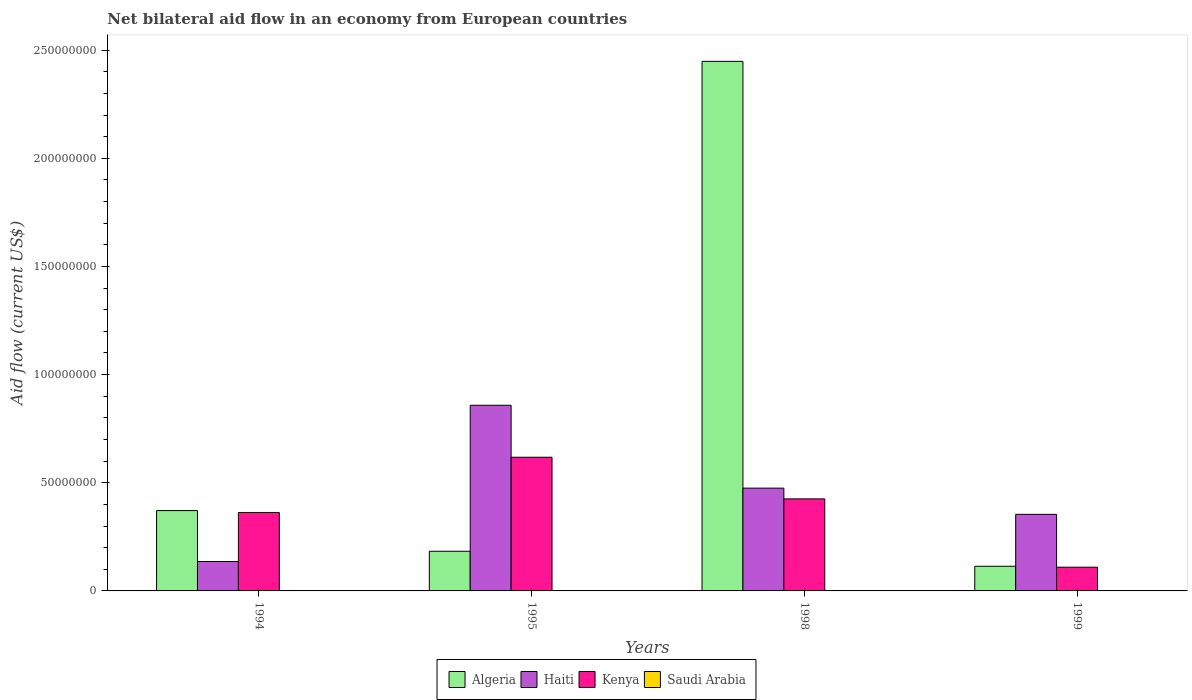How many bars are there on the 3rd tick from the left?
Offer a terse response. 4. What is the label of the 3rd group of bars from the left?
Offer a very short reply. 1998. In how many cases, is the number of bars for a given year not equal to the number of legend labels?
Offer a terse response. 0. What is the net bilateral aid flow in Kenya in 1998?
Offer a very short reply. 4.25e+07. Across all years, what is the maximum net bilateral aid flow in Haiti?
Your answer should be compact. 8.58e+07. Across all years, what is the minimum net bilateral aid flow in Algeria?
Your answer should be very brief. 1.14e+07. In which year was the net bilateral aid flow in Algeria maximum?
Provide a succinct answer. 1998. What is the total net bilateral aid flow in Algeria in the graph?
Your answer should be very brief. 3.12e+08. What is the difference between the net bilateral aid flow in Algeria in 1998 and the net bilateral aid flow in Kenya in 1995?
Your response must be concise. 1.83e+08. What is the average net bilateral aid flow in Algeria per year?
Provide a succinct answer. 7.79e+07. In the year 1994, what is the difference between the net bilateral aid flow in Algeria and net bilateral aid flow in Kenya?
Provide a succinct answer. 8.90e+05. In how many years, is the net bilateral aid flow in Algeria greater than 50000000 US$?
Offer a terse response. 1. What is the ratio of the net bilateral aid flow in Kenya in 1995 to that in 1998?
Your answer should be compact. 1.45. Is the net bilateral aid flow in Saudi Arabia in 1998 less than that in 1999?
Your response must be concise. Yes. What is the difference between the highest and the second highest net bilateral aid flow in Kenya?
Your answer should be very brief. 1.93e+07. What is the difference between the highest and the lowest net bilateral aid flow in Algeria?
Ensure brevity in your answer.  2.33e+08. Is it the case that in every year, the sum of the net bilateral aid flow in Haiti and net bilateral aid flow in Kenya is greater than the sum of net bilateral aid flow in Saudi Arabia and net bilateral aid flow in Algeria?
Give a very brief answer. No. What does the 2nd bar from the left in 1999 represents?
Offer a terse response. Haiti. What does the 2nd bar from the right in 1994 represents?
Offer a very short reply. Kenya. How many bars are there?
Offer a terse response. 16. Are all the bars in the graph horizontal?
Give a very brief answer. No. What is the difference between two consecutive major ticks on the Y-axis?
Ensure brevity in your answer.  5.00e+07. Does the graph contain any zero values?
Keep it short and to the point. No. Does the graph contain grids?
Your answer should be very brief. No. Where does the legend appear in the graph?
Provide a succinct answer. Bottom center. How many legend labels are there?
Your response must be concise. 4. What is the title of the graph?
Your answer should be very brief. Net bilateral aid flow in an economy from European countries. What is the label or title of the X-axis?
Give a very brief answer. Years. What is the Aid flow (current US$) of Algeria in 1994?
Keep it short and to the point. 3.71e+07. What is the Aid flow (current US$) of Haiti in 1994?
Offer a terse response. 1.36e+07. What is the Aid flow (current US$) in Kenya in 1994?
Keep it short and to the point. 3.62e+07. What is the Aid flow (current US$) in Algeria in 1995?
Give a very brief answer. 1.83e+07. What is the Aid flow (current US$) of Haiti in 1995?
Ensure brevity in your answer.  8.58e+07. What is the Aid flow (current US$) in Kenya in 1995?
Make the answer very short. 6.18e+07. What is the Aid flow (current US$) of Algeria in 1998?
Give a very brief answer. 2.45e+08. What is the Aid flow (current US$) of Haiti in 1998?
Provide a short and direct response. 4.75e+07. What is the Aid flow (current US$) in Kenya in 1998?
Make the answer very short. 4.25e+07. What is the Aid flow (current US$) of Saudi Arabia in 1998?
Your answer should be very brief. 10000. What is the Aid flow (current US$) in Algeria in 1999?
Offer a terse response. 1.14e+07. What is the Aid flow (current US$) of Haiti in 1999?
Your answer should be very brief. 3.54e+07. What is the Aid flow (current US$) in Kenya in 1999?
Provide a succinct answer. 1.10e+07. What is the Aid flow (current US$) in Saudi Arabia in 1999?
Provide a succinct answer. 8.00e+04. Across all years, what is the maximum Aid flow (current US$) of Algeria?
Your response must be concise. 2.45e+08. Across all years, what is the maximum Aid flow (current US$) of Haiti?
Ensure brevity in your answer.  8.58e+07. Across all years, what is the maximum Aid flow (current US$) of Kenya?
Give a very brief answer. 6.18e+07. Across all years, what is the maximum Aid flow (current US$) in Saudi Arabia?
Provide a short and direct response. 1.60e+05. Across all years, what is the minimum Aid flow (current US$) in Algeria?
Provide a short and direct response. 1.14e+07. Across all years, what is the minimum Aid flow (current US$) of Haiti?
Ensure brevity in your answer.  1.36e+07. Across all years, what is the minimum Aid flow (current US$) in Kenya?
Keep it short and to the point. 1.10e+07. What is the total Aid flow (current US$) of Algeria in the graph?
Ensure brevity in your answer.  3.12e+08. What is the total Aid flow (current US$) in Haiti in the graph?
Ensure brevity in your answer.  1.82e+08. What is the total Aid flow (current US$) in Kenya in the graph?
Offer a very short reply. 1.52e+08. What is the total Aid flow (current US$) in Saudi Arabia in the graph?
Provide a succinct answer. 3.60e+05. What is the difference between the Aid flow (current US$) of Algeria in 1994 and that in 1995?
Your answer should be very brief. 1.88e+07. What is the difference between the Aid flow (current US$) in Haiti in 1994 and that in 1995?
Make the answer very short. -7.22e+07. What is the difference between the Aid flow (current US$) of Kenya in 1994 and that in 1995?
Offer a terse response. -2.56e+07. What is the difference between the Aid flow (current US$) in Saudi Arabia in 1994 and that in 1995?
Your response must be concise. -5.00e+04. What is the difference between the Aid flow (current US$) of Algeria in 1994 and that in 1998?
Give a very brief answer. -2.08e+08. What is the difference between the Aid flow (current US$) of Haiti in 1994 and that in 1998?
Your answer should be compact. -3.39e+07. What is the difference between the Aid flow (current US$) in Kenya in 1994 and that in 1998?
Your answer should be compact. -6.29e+06. What is the difference between the Aid flow (current US$) of Saudi Arabia in 1994 and that in 1998?
Your answer should be very brief. 1.00e+05. What is the difference between the Aid flow (current US$) in Algeria in 1994 and that in 1999?
Your answer should be very brief. 2.57e+07. What is the difference between the Aid flow (current US$) in Haiti in 1994 and that in 1999?
Your answer should be compact. -2.18e+07. What is the difference between the Aid flow (current US$) of Kenya in 1994 and that in 1999?
Give a very brief answer. 2.53e+07. What is the difference between the Aid flow (current US$) in Algeria in 1995 and that in 1998?
Provide a short and direct response. -2.26e+08. What is the difference between the Aid flow (current US$) in Haiti in 1995 and that in 1998?
Offer a very short reply. 3.83e+07. What is the difference between the Aid flow (current US$) in Kenya in 1995 and that in 1998?
Provide a short and direct response. 1.93e+07. What is the difference between the Aid flow (current US$) of Saudi Arabia in 1995 and that in 1998?
Offer a terse response. 1.50e+05. What is the difference between the Aid flow (current US$) of Algeria in 1995 and that in 1999?
Offer a terse response. 6.94e+06. What is the difference between the Aid flow (current US$) of Haiti in 1995 and that in 1999?
Keep it short and to the point. 5.04e+07. What is the difference between the Aid flow (current US$) of Kenya in 1995 and that in 1999?
Give a very brief answer. 5.08e+07. What is the difference between the Aid flow (current US$) of Algeria in 1998 and that in 1999?
Offer a very short reply. 2.33e+08. What is the difference between the Aid flow (current US$) in Haiti in 1998 and that in 1999?
Your response must be concise. 1.21e+07. What is the difference between the Aid flow (current US$) in Kenya in 1998 and that in 1999?
Ensure brevity in your answer.  3.16e+07. What is the difference between the Aid flow (current US$) in Saudi Arabia in 1998 and that in 1999?
Make the answer very short. -7.00e+04. What is the difference between the Aid flow (current US$) of Algeria in 1994 and the Aid flow (current US$) of Haiti in 1995?
Make the answer very short. -4.87e+07. What is the difference between the Aid flow (current US$) of Algeria in 1994 and the Aid flow (current US$) of Kenya in 1995?
Your answer should be very brief. -2.47e+07. What is the difference between the Aid flow (current US$) of Algeria in 1994 and the Aid flow (current US$) of Saudi Arabia in 1995?
Your response must be concise. 3.70e+07. What is the difference between the Aid flow (current US$) of Haiti in 1994 and the Aid flow (current US$) of Kenya in 1995?
Give a very brief answer. -4.82e+07. What is the difference between the Aid flow (current US$) in Haiti in 1994 and the Aid flow (current US$) in Saudi Arabia in 1995?
Provide a succinct answer. 1.34e+07. What is the difference between the Aid flow (current US$) in Kenya in 1994 and the Aid flow (current US$) in Saudi Arabia in 1995?
Ensure brevity in your answer.  3.61e+07. What is the difference between the Aid flow (current US$) of Algeria in 1994 and the Aid flow (current US$) of Haiti in 1998?
Provide a succinct answer. -1.04e+07. What is the difference between the Aid flow (current US$) of Algeria in 1994 and the Aid flow (current US$) of Kenya in 1998?
Offer a very short reply. -5.40e+06. What is the difference between the Aid flow (current US$) in Algeria in 1994 and the Aid flow (current US$) in Saudi Arabia in 1998?
Offer a terse response. 3.71e+07. What is the difference between the Aid flow (current US$) in Haiti in 1994 and the Aid flow (current US$) in Kenya in 1998?
Make the answer very short. -2.89e+07. What is the difference between the Aid flow (current US$) of Haiti in 1994 and the Aid flow (current US$) of Saudi Arabia in 1998?
Ensure brevity in your answer.  1.36e+07. What is the difference between the Aid flow (current US$) in Kenya in 1994 and the Aid flow (current US$) in Saudi Arabia in 1998?
Offer a terse response. 3.62e+07. What is the difference between the Aid flow (current US$) of Algeria in 1994 and the Aid flow (current US$) of Haiti in 1999?
Make the answer very short. 1.74e+06. What is the difference between the Aid flow (current US$) in Algeria in 1994 and the Aid flow (current US$) in Kenya in 1999?
Your response must be concise. 2.62e+07. What is the difference between the Aid flow (current US$) of Algeria in 1994 and the Aid flow (current US$) of Saudi Arabia in 1999?
Provide a succinct answer. 3.71e+07. What is the difference between the Aid flow (current US$) of Haiti in 1994 and the Aid flow (current US$) of Kenya in 1999?
Your answer should be compact. 2.63e+06. What is the difference between the Aid flow (current US$) of Haiti in 1994 and the Aid flow (current US$) of Saudi Arabia in 1999?
Keep it short and to the point. 1.35e+07. What is the difference between the Aid flow (current US$) in Kenya in 1994 and the Aid flow (current US$) in Saudi Arabia in 1999?
Ensure brevity in your answer.  3.62e+07. What is the difference between the Aid flow (current US$) of Algeria in 1995 and the Aid flow (current US$) of Haiti in 1998?
Offer a terse response. -2.92e+07. What is the difference between the Aid flow (current US$) of Algeria in 1995 and the Aid flow (current US$) of Kenya in 1998?
Your answer should be very brief. -2.42e+07. What is the difference between the Aid flow (current US$) of Algeria in 1995 and the Aid flow (current US$) of Saudi Arabia in 1998?
Provide a short and direct response. 1.83e+07. What is the difference between the Aid flow (current US$) of Haiti in 1995 and the Aid flow (current US$) of Kenya in 1998?
Keep it short and to the point. 4.33e+07. What is the difference between the Aid flow (current US$) in Haiti in 1995 and the Aid flow (current US$) in Saudi Arabia in 1998?
Your response must be concise. 8.58e+07. What is the difference between the Aid flow (current US$) of Kenya in 1995 and the Aid flow (current US$) of Saudi Arabia in 1998?
Ensure brevity in your answer.  6.18e+07. What is the difference between the Aid flow (current US$) of Algeria in 1995 and the Aid flow (current US$) of Haiti in 1999?
Provide a short and direct response. -1.71e+07. What is the difference between the Aid flow (current US$) of Algeria in 1995 and the Aid flow (current US$) of Kenya in 1999?
Offer a very short reply. 7.37e+06. What is the difference between the Aid flow (current US$) in Algeria in 1995 and the Aid flow (current US$) in Saudi Arabia in 1999?
Provide a short and direct response. 1.83e+07. What is the difference between the Aid flow (current US$) of Haiti in 1995 and the Aid flow (current US$) of Kenya in 1999?
Give a very brief answer. 7.49e+07. What is the difference between the Aid flow (current US$) in Haiti in 1995 and the Aid flow (current US$) in Saudi Arabia in 1999?
Provide a short and direct response. 8.58e+07. What is the difference between the Aid flow (current US$) in Kenya in 1995 and the Aid flow (current US$) in Saudi Arabia in 1999?
Offer a very short reply. 6.17e+07. What is the difference between the Aid flow (current US$) in Algeria in 1998 and the Aid flow (current US$) in Haiti in 1999?
Provide a short and direct response. 2.09e+08. What is the difference between the Aid flow (current US$) in Algeria in 1998 and the Aid flow (current US$) in Kenya in 1999?
Your answer should be compact. 2.34e+08. What is the difference between the Aid flow (current US$) of Algeria in 1998 and the Aid flow (current US$) of Saudi Arabia in 1999?
Provide a short and direct response. 2.45e+08. What is the difference between the Aid flow (current US$) in Haiti in 1998 and the Aid flow (current US$) in Kenya in 1999?
Make the answer very short. 3.66e+07. What is the difference between the Aid flow (current US$) in Haiti in 1998 and the Aid flow (current US$) in Saudi Arabia in 1999?
Make the answer very short. 4.74e+07. What is the difference between the Aid flow (current US$) in Kenya in 1998 and the Aid flow (current US$) in Saudi Arabia in 1999?
Make the answer very short. 4.25e+07. What is the average Aid flow (current US$) in Algeria per year?
Ensure brevity in your answer.  7.79e+07. What is the average Aid flow (current US$) of Haiti per year?
Provide a short and direct response. 4.56e+07. What is the average Aid flow (current US$) of Kenya per year?
Offer a terse response. 3.79e+07. What is the average Aid flow (current US$) in Saudi Arabia per year?
Your answer should be very brief. 9.00e+04. In the year 1994, what is the difference between the Aid flow (current US$) in Algeria and Aid flow (current US$) in Haiti?
Offer a very short reply. 2.35e+07. In the year 1994, what is the difference between the Aid flow (current US$) of Algeria and Aid flow (current US$) of Kenya?
Make the answer very short. 8.90e+05. In the year 1994, what is the difference between the Aid flow (current US$) of Algeria and Aid flow (current US$) of Saudi Arabia?
Your answer should be compact. 3.70e+07. In the year 1994, what is the difference between the Aid flow (current US$) in Haiti and Aid flow (current US$) in Kenya?
Your response must be concise. -2.26e+07. In the year 1994, what is the difference between the Aid flow (current US$) of Haiti and Aid flow (current US$) of Saudi Arabia?
Your answer should be very brief. 1.35e+07. In the year 1994, what is the difference between the Aid flow (current US$) of Kenya and Aid flow (current US$) of Saudi Arabia?
Your answer should be compact. 3.61e+07. In the year 1995, what is the difference between the Aid flow (current US$) of Algeria and Aid flow (current US$) of Haiti?
Provide a succinct answer. -6.75e+07. In the year 1995, what is the difference between the Aid flow (current US$) in Algeria and Aid flow (current US$) in Kenya?
Your answer should be compact. -4.35e+07. In the year 1995, what is the difference between the Aid flow (current US$) of Algeria and Aid flow (current US$) of Saudi Arabia?
Keep it short and to the point. 1.82e+07. In the year 1995, what is the difference between the Aid flow (current US$) of Haiti and Aid flow (current US$) of Kenya?
Provide a short and direct response. 2.40e+07. In the year 1995, what is the difference between the Aid flow (current US$) of Haiti and Aid flow (current US$) of Saudi Arabia?
Offer a terse response. 8.57e+07. In the year 1995, what is the difference between the Aid flow (current US$) of Kenya and Aid flow (current US$) of Saudi Arabia?
Offer a very short reply. 6.16e+07. In the year 1998, what is the difference between the Aid flow (current US$) of Algeria and Aid flow (current US$) of Haiti?
Provide a short and direct response. 1.97e+08. In the year 1998, what is the difference between the Aid flow (current US$) of Algeria and Aid flow (current US$) of Kenya?
Keep it short and to the point. 2.02e+08. In the year 1998, what is the difference between the Aid flow (current US$) of Algeria and Aid flow (current US$) of Saudi Arabia?
Ensure brevity in your answer.  2.45e+08. In the year 1998, what is the difference between the Aid flow (current US$) of Haiti and Aid flow (current US$) of Kenya?
Ensure brevity in your answer.  4.98e+06. In the year 1998, what is the difference between the Aid flow (current US$) of Haiti and Aid flow (current US$) of Saudi Arabia?
Your response must be concise. 4.75e+07. In the year 1998, what is the difference between the Aid flow (current US$) of Kenya and Aid flow (current US$) of Saudi Arabia?
Give a very brief answer. 4.25e+07. In the year 1999, what is the difference between the Aid flow (current US$) of Algeria and Aid flow (current US$) of Haiti?
Make the answer very short. -2.40e+07. In the year 1999, what is the difference between the Aid flow (current US$) of Algeria and Aid flow (current US$) of Saudi Arabia?
Make the answer very short. 1.13e+07. In the year 1999, what is the difference between the Aid flow (current US$) of Haiti and Aid flow (current US$) of Kenya?
Your response must be concise. 2.44e+07. In the year 1999, what is the difference between the Aid flow (current US$) of Haiti and Aid flow (current US$) of Saudi Arabia?
Your answer should be compact. 3.53e+07. In the year 1999, what is the difference between the Aid flow (current US$) in Kenya and Aid flow (current US$) in Saudi Arabia?
Keep it short and to the point. 1.09e+07. What is the ratio of the Aid flow (current US$) in Algeria in 1994 to that in 1995?
Your response must be concise. 2.03. What is the ratio of the Aid flow (current US$) of Haiti in 1994 to that in 1995?
Offer a very short reply. 0.16. What is the ratio of the Aid flow (current US$) in Kenya in 1994 to that in 1995?
Offer a very short reply. 0.59. What is the ratio of the Aid flow (current US$) in Saudi Arabia in 1994 to that in 1995?
Offer a very short reply. 0.69. What is the ratio of the Aid flow (current US$) in Algeria in 1994 to that in 1998?
Offer a terse response. 0.15. What is the ratio of the Aid flow (current US$) in Haiti in 1994 to that in 1998?
Ensure brevity in your answer.  0.29. What is the ratio of the Aid flow (current US$) of Kenya in 1994 to that in 1998?
Offer a terse response. 0.85. What is the ratio of the Aid flow (current US$) of Saudi Arabia in 1994 to that in 1998?
Make the answer very short. 11. What is the ratio of the Aid flow (current US$) of Algeria in 1994 to that in 1999?
Your answer should be very brief. 3.26. What is the ratio of the Aid flow (current US$) in Haiti in 1994 to that in 1999?
Offer a very short reply. 0.38. What is the ratio of the Aid flow (current US$) of Kenya in 1994 to that in 1999?
Your answer should be very brief. 3.3. What is the ratio of the Aid flow (current US$) in Saudi Arabia in 1994 to that in 1999?
Provide a succinct answer. 1.38. What is the ratio of the Aid flow (current US$) in Algeria in 1995 to that in 1998?
Your answer should be very brief. 0.07. What is the ratio of the Aid flow (current US$) in Haiti in 1995 to that in 1998?
Give a very brief answer. 1.81. What is the ratio of the Aid flow (current US$) of Kenya in 1995 to that in 1998?
Make the answer very short. 1.45. What is the ratio of the Aid flow (current US$) in Algeria in 1995 to that in 1999?
Keep it short and to the point. 1.61. What is the ratio of the Aid flow (current US$) in Haiti in 1995 to that in 1999?
Your answer should be compact. 2.42. What is the ratio of the Aid flow (current US$) of Kenya in 1995 to that in 1999?
Give a very brief answer. 5.63. What is the ratio of the Aid flow (current US$) in Algeria in 1998 to that in 1999?
Your answer should be very brief. 21.48. What is the ratio of the Aid flow (current US$) in Haiti in 1998 to that in 1999?
Your response must be concise. 1.34. What is the ratio of the Aid flow (current US$) of Kenya in 1998 to that in 1999?
Offer a terse response. 3.88. What is the ratio of the Aid flow (current US$) in Saudi Arabia in 1998 to that in 1999?
Provide a succinct answer. 0.12. What is the difference between the highest and the second highest Aid flow (current US$) in Algeria?
Ensure brevity in your answer.  2.08e+08. What is the difference between the highest and the second highest Aid flow (current US$) in Haiti?
Keep it short and to the point. 3.83e+07. What is the difference between the highest and the second highest Aid flow (current US$) in Kenya?
Provide a succinct answer. 1.93e+07. What is the difference between the highest and the second highest Aid flow (current US$) of Saudi Arabia?
Your answer should be compact. 5.00e+04. What is the difference between the highest and the lowest Aid flow (current US$) of Algeria?
Your answer should be compact. 2.33e+08. What is the difference between the highest and the lowest Aid flow (current US$) of Haiti?
Your response must be concise. 7.22e+07. What is the difference between the highest and the lowest Aid flow (current US$) of Kenya?
Your answer should be very brief. 5.08e+07. What is the difference between the highest and the lowest Aid flow (current US$) in Saudi Arabia?
Offer a terse response. 1.50e+05. 